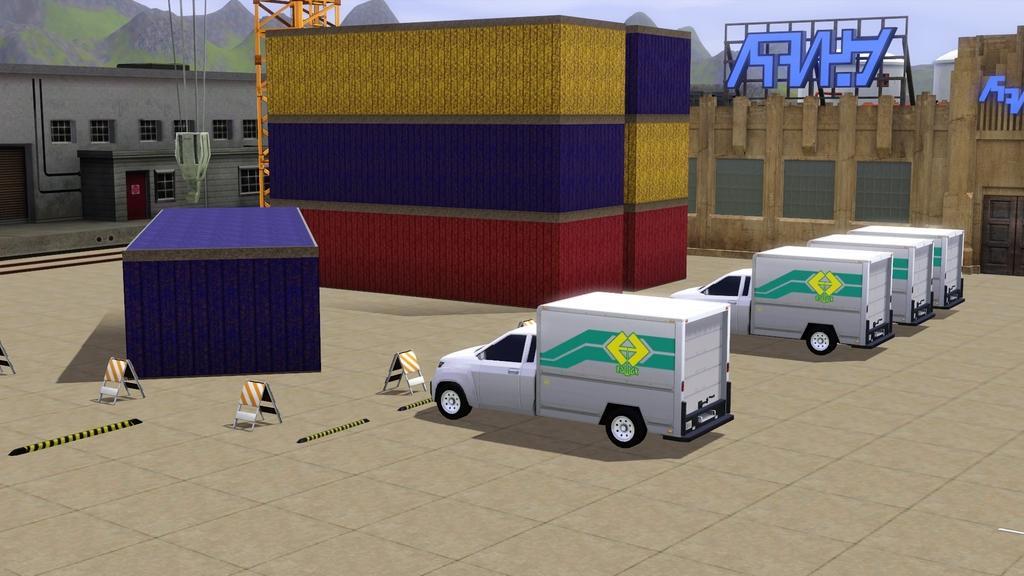Could you give a brief overview of what you see in this image? In this picture we can see cartoon images of few vehicles, containers, buildings, hills and hoardings. 